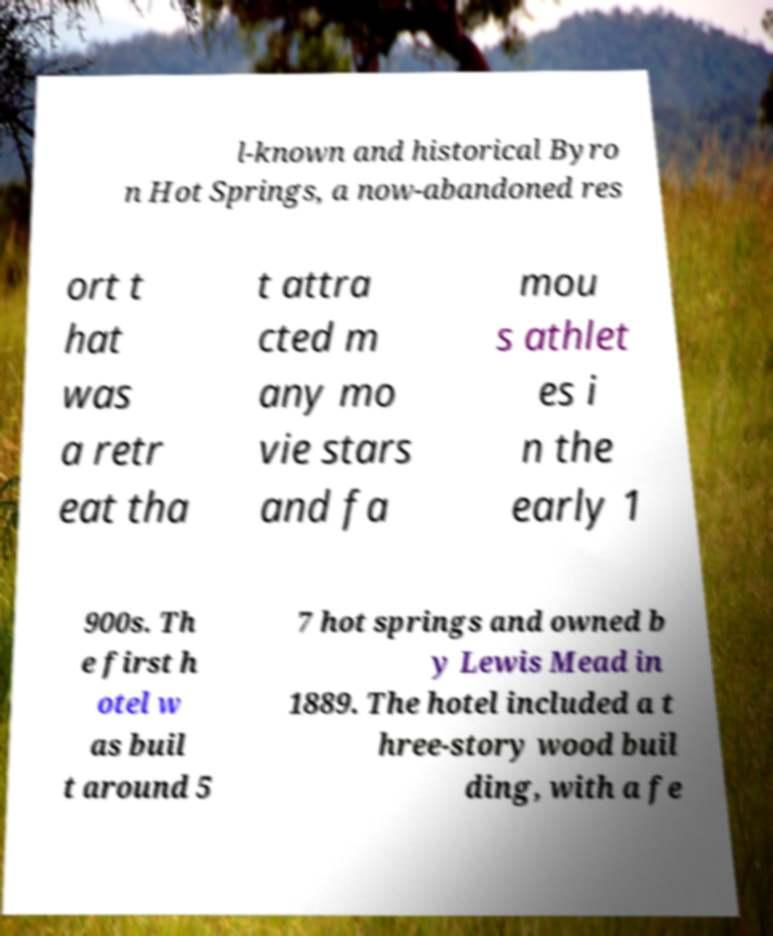What messages or text are displayed in this image? I need them in a readable, typed format. l-known and historical Byro n Hot Springs, a now-abandoned res ort t hat was a retr eat tha t attra cted m any mo vie stars and fa mou s athlet es i n the early 1 900s. Th e first h otel w as buil t around 5 7 hot springs and owned b y Lewis Mead in 1889. The hotel included a t hree-story wood buil ding, with a fe 